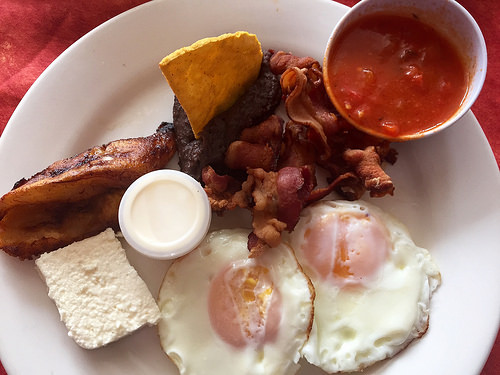<image>
Can you confirm if the bacon is on the egg? Yes. Looking at the image, I can see the bacon is positioned on top of the egg, with the egg providing support. Is the egg to the left of the salsa? Yes. From this viewpoint, the egg is positioned to the left side relative to the salsa. Is there a bacon next to the table? No. The bacon is not positioned next to the table. They are located in different areas of the scene. 